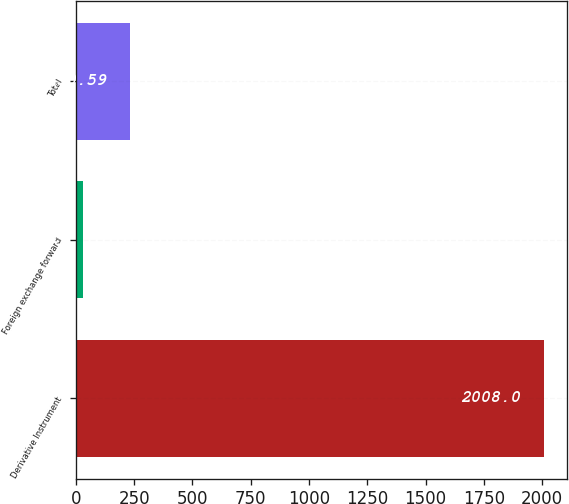Convert chart. <chart><loc_0><loc_0><loc_500><loc_500><bar_chart><fcel>Derivative Instrument<fcel>Foreign exchange forward<fcel>Total<nl><fcel>2008<fcel>33.1<fcel>230.59<nl></chart> 